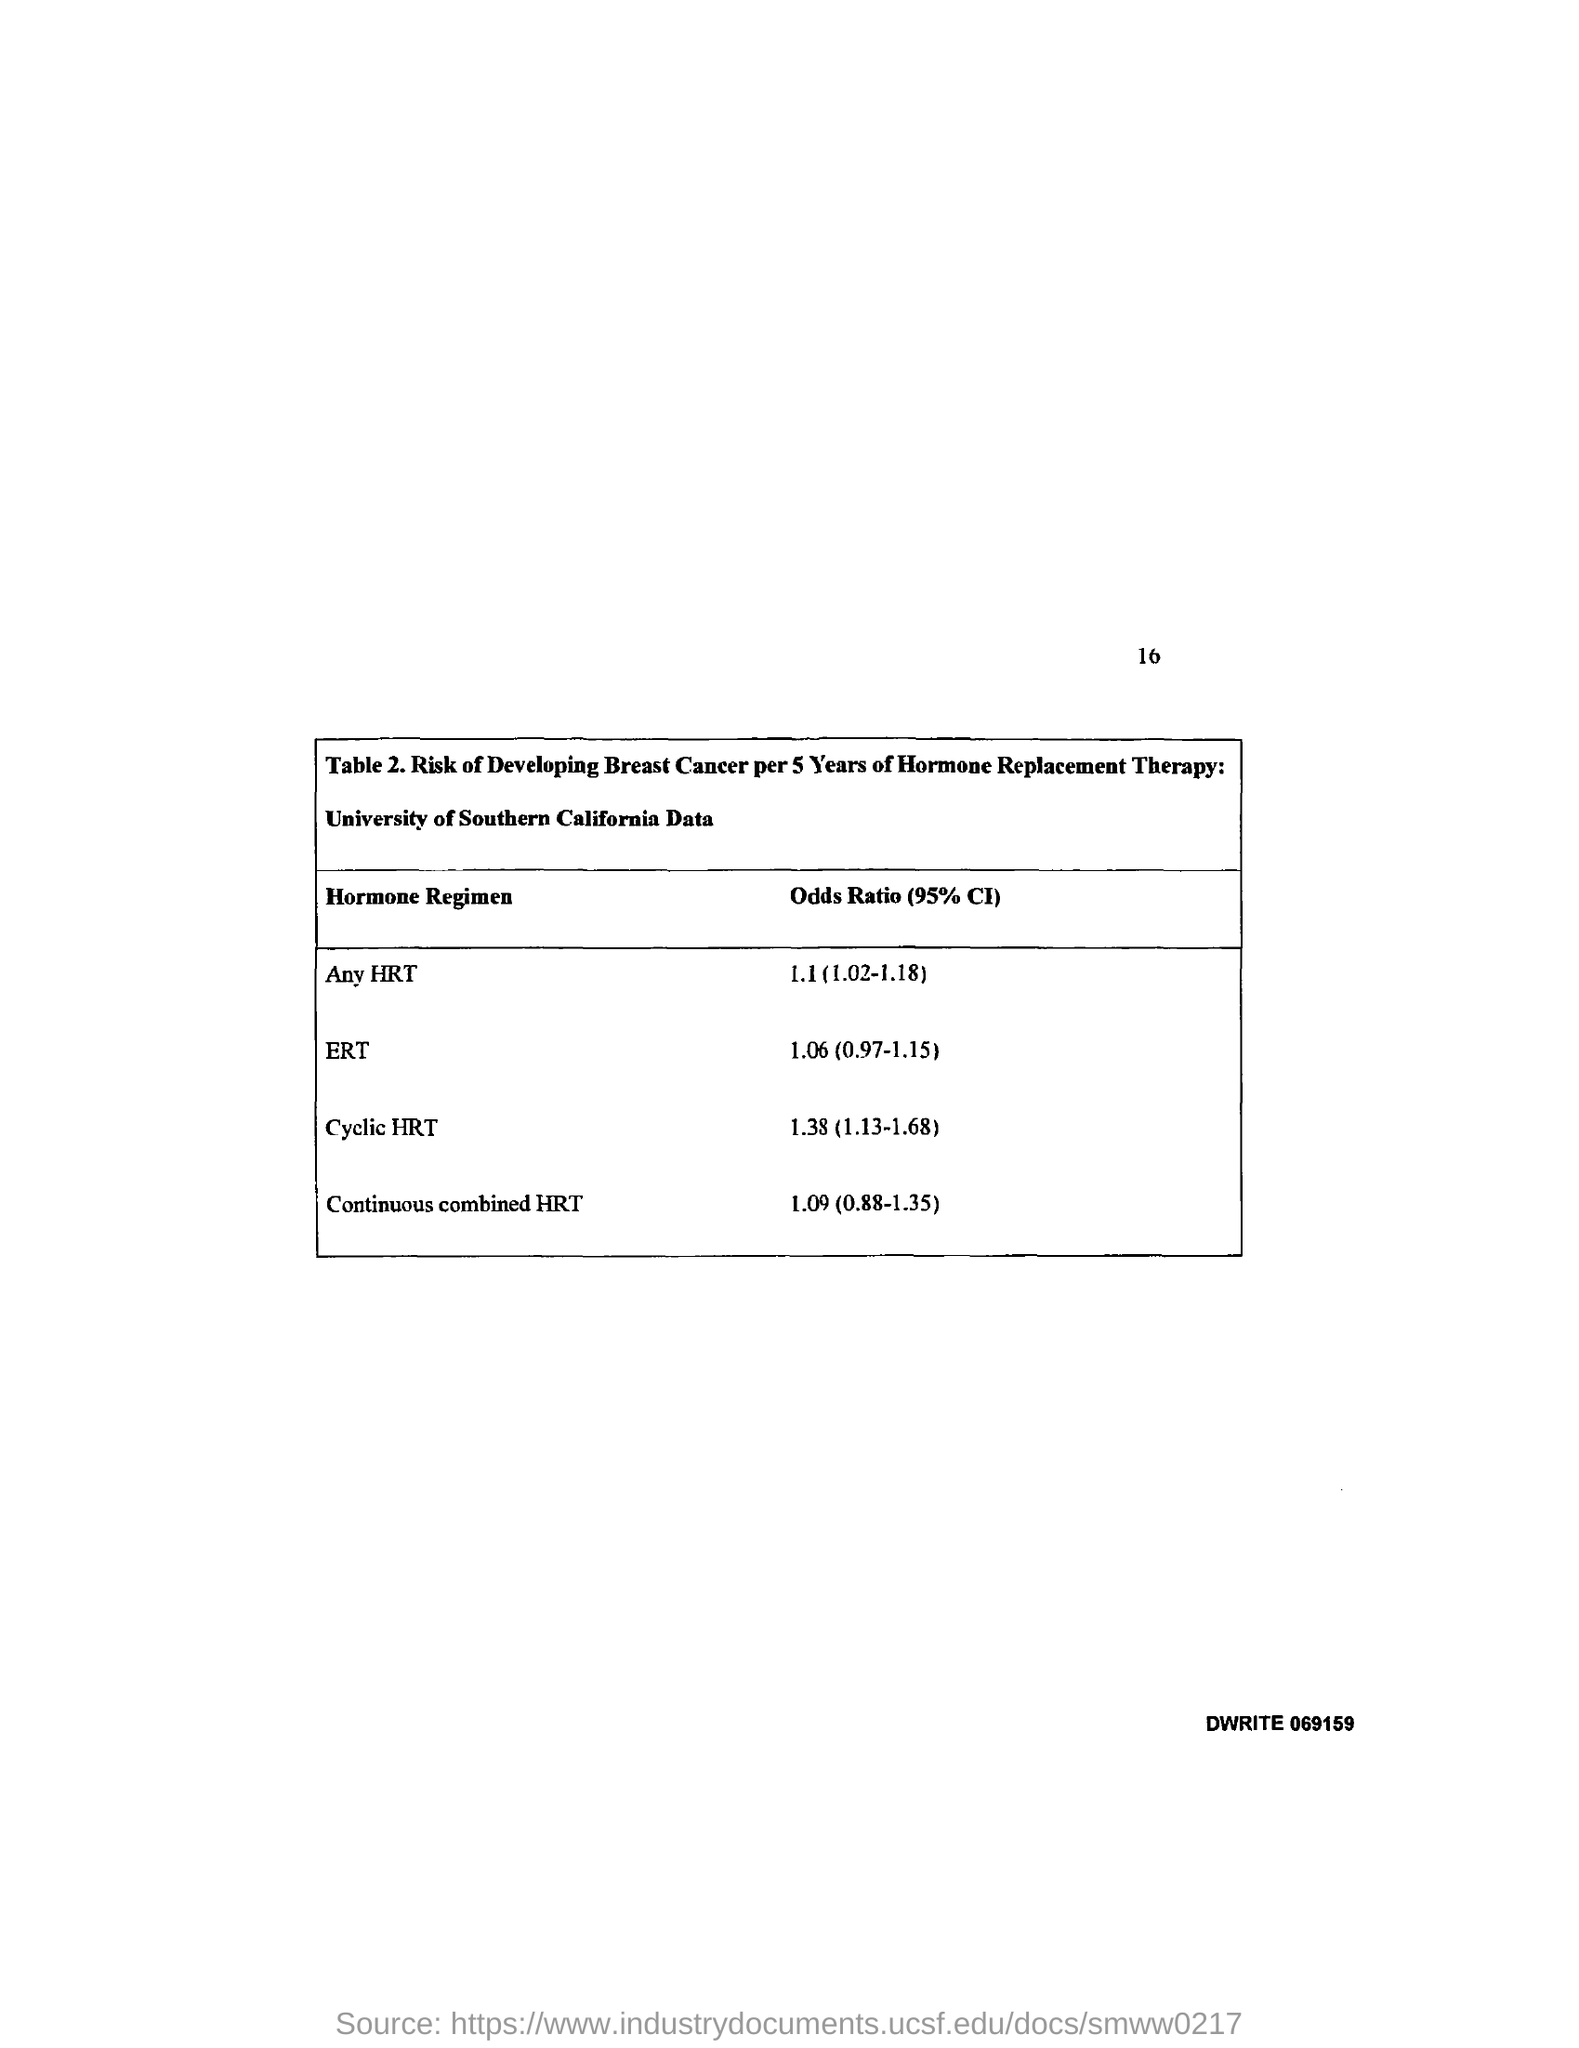Specify some key components in this picture. The odds ratio (95% CI) for any HRT is 1.1 (1.02-1.18), indicating a small but statistically significant increase in the risk of developing breast cancer among women who use HRT compared to those who do not. The odds ratio (95% CI) for cyclic hormone replacement therapy (HRT) is 1.38 (1.13-1.68). This means that for every 1 unit increase in exposure to cyclic HRT, the risk of endometrial cancer increases by 1.38 times (95% CI: 1.13-1.68). The odds ratio (95% CI) for ERT is 1.06 (0.97-1.15), which indicates that the odds of experiencing a treatment-related adverse event are 1.06 times higher in the ERT group compared to the control group, with a range of 97% confidence interval from 0.97 to 1.15. 